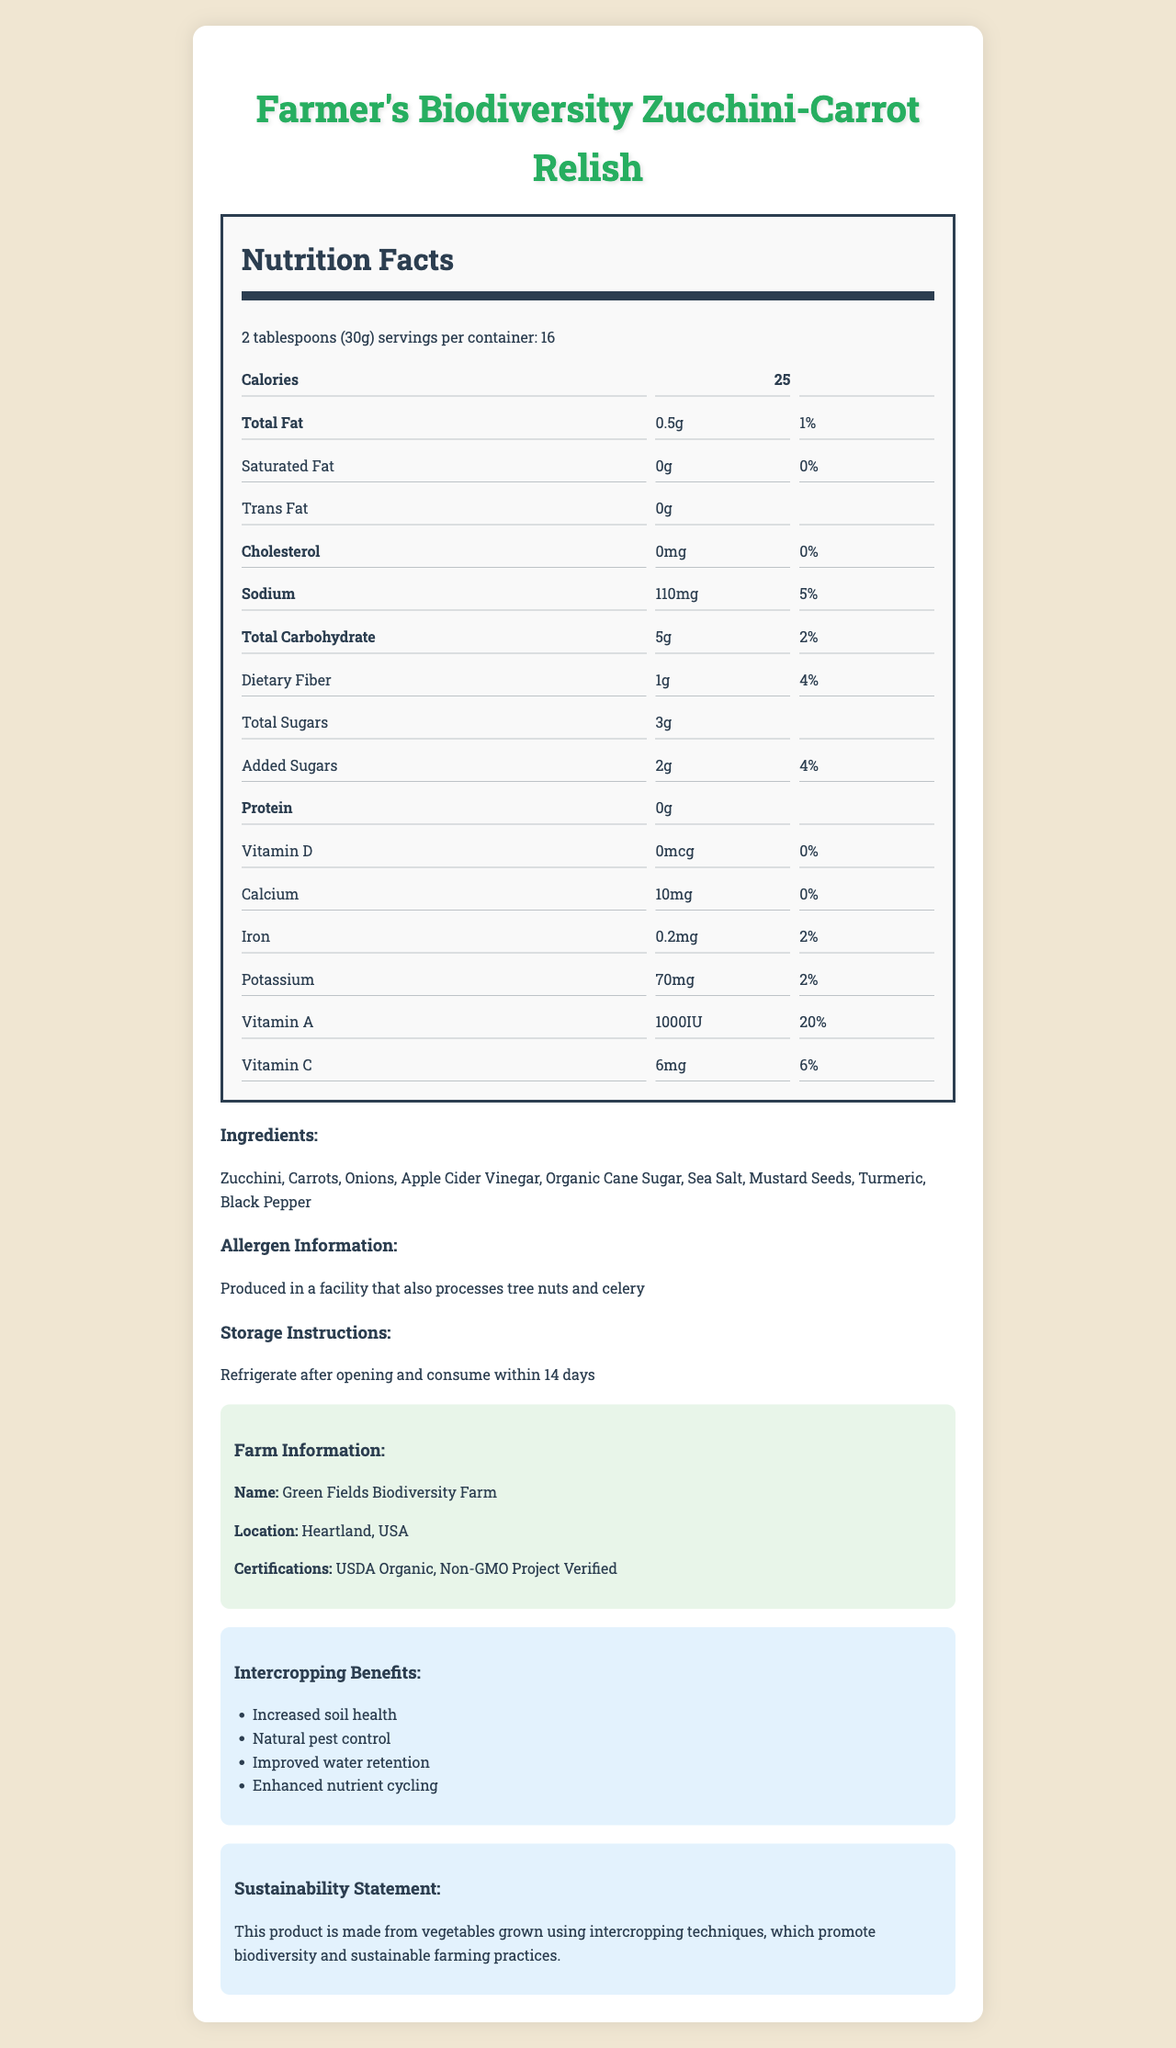what is the serving size of Farmer's Biodiversity Zucchini-Carrot Relish? The serving size is listed at the top of the Nutrition Facts section.
Answer: 2 tablespoons (30g) how many calories are in one serving? The calories per serving are displayed in bold under Calories.
Answer: 25 what is the total amount of fat in one serving? The total fat amount is shown as 0.5g under the Total Fat section.
Answer: 0.5g what is the daily value percentage of sodium? The daily value percentage for sodium is shown next to the sodium amount.
Answer: 5% which vitamins are included in the nutrition facts? The listed vitamins are Vitamin D, Vitamin A, and Vitamin C, each with their corresponding amounts and daily values.
Answer: Vitamin D, Vitamin A, Vitamin C how much dietary fiber is in one serving? The dietary fiber content is indicated as 1g under the Dietary Fiber section.
Answer: 1g what are the ingredients in Farmer's Biodiversity Zucchini-Carrot Relish? A. Zucchini, Carrots, Onions B. Apple Cider Vinegar, Organic Cane Sugar C. Sea Salt, Mustard Seeds, Turmeric, Black Pepper D. All of the above The Ingredients section lists all components including vegetables, vinegar, sugar, and spices.
Answer: D what is the serving size in grams? A. 25g B. 30g C. 35g The serving size is given as 2 tablespoons, which equals to 30g.
Answer: B Is the relish produced in a facility that processes peanuts? The allergen information specifies tree nuts and celery, but not peanuts.
Answer: No what is the storage instruction after opening the product? The Storage Instructions section clearly states the product should be refrigerated after opening and consumed within 14 days.
Answer: Refrigerate after opening and consume within 14 days does the product contain any trans fat? The Trans Fat section states the amount as 0g, indicating no trans fat present.
Answer: No what is the sodium amount per serving? Sodium content per serving is listed as 110mg in the Nutrition Facts.
Answer: 110mg describe the certifications of the farm that produced the vegetables. The Farm Information section lists the two certifications: USDA Organic and Non-GMO Project Verified.
Answer: The farm has USDA Organic and Non-GMO Project Verified certifications what is the total carbohydrate content per serving? The amount of total carbohydrates per serving is mentioned as 5g.
Answer: 5g what is the exact name and location of the farm producing this product? The Farm Information section provides both the name and location of the farm.
Answer: Green Fields Biodiversity Farm, Heartland, USA how many servings are there in a container? The number of servings per container is specified in the Nutrition Facts.
Answer: 16 Summarize the main idea of the document. The document thoroughly describes the product, highlighting its health benefits, sustainable production methods, and the farm's certifications, aiming to inform and attract health-conscious and environmentally-aware consumers.
Answer: The document provides detailed information about Farmer's Biodiversity Zucchini-Carrot Relish, including its nutritional facts, ingredients, allergen information, storage instructions, farm details, intercropping benefits, and sustainability statement. The product is aimed at promoting biodiversity and sustainable farming practices. what is the potassium daily value percentage? The daily value for potassium is listed as 2% next to the potassium amount.
Answer: 2% How much iron is present in one serving? The iron content per serving is 0.2mg as listed in the Nutrition Facts.
Answer: 0.2mg Where is the farm located? The farm's location is specified in the Farm Information section.
Answer: Heartland, USA How much of the product can be consumed before the daily value of total carbohydrates is reached? The document provides the daily value percentage for a single serving but does not give a limit for total carbohydrate intake for the day.
Answer: Not enough information 